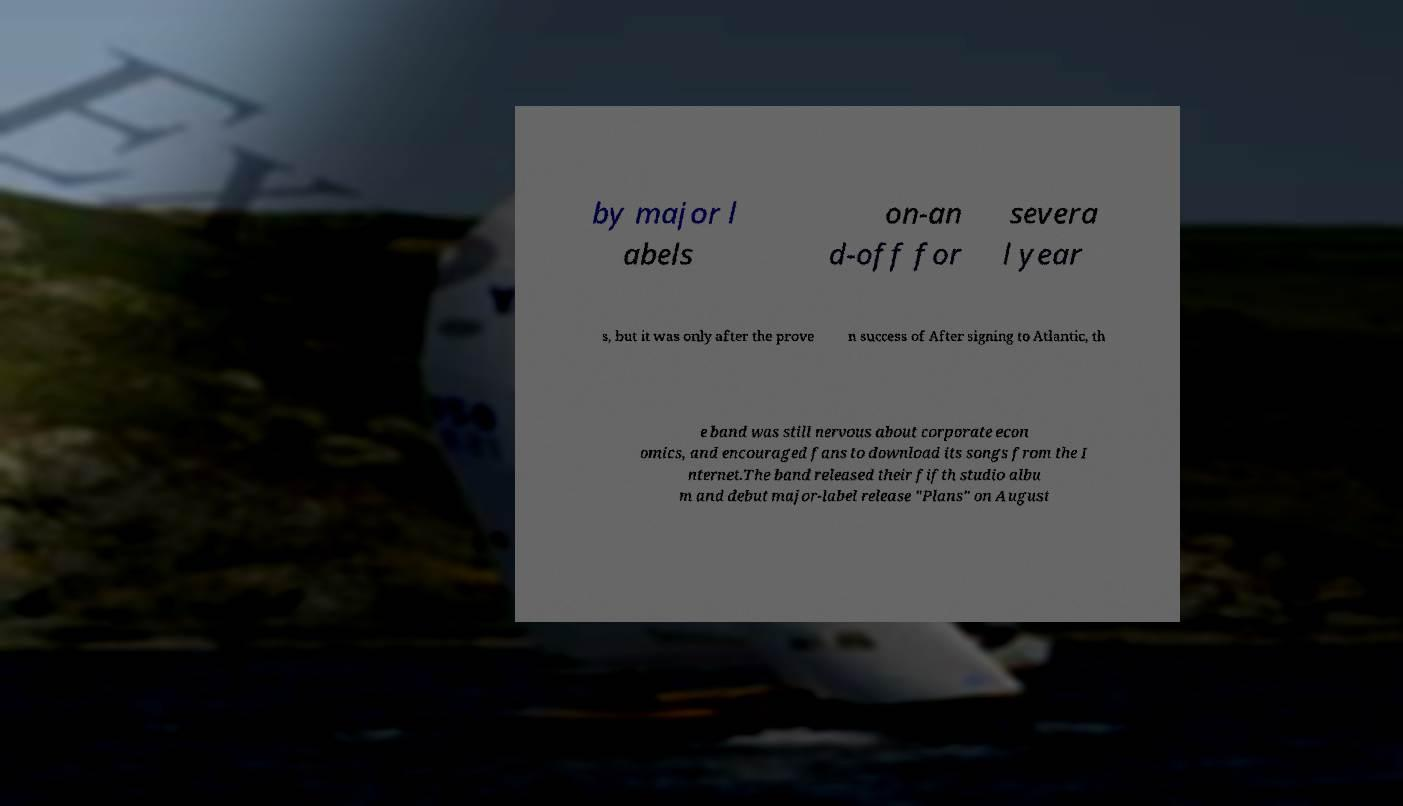What messages or text are displayed in this image? I need them in a readable, typed format. by major l abels on-an d-off for severa l year s, but it was only after the prove n success of After signing to Atlantic, th e band was still nervous about corporate econ omics, and encouraged fans to download its songs from the I nternet.The band released their fifth studio albu m and debut major-label release "Plans" on August 